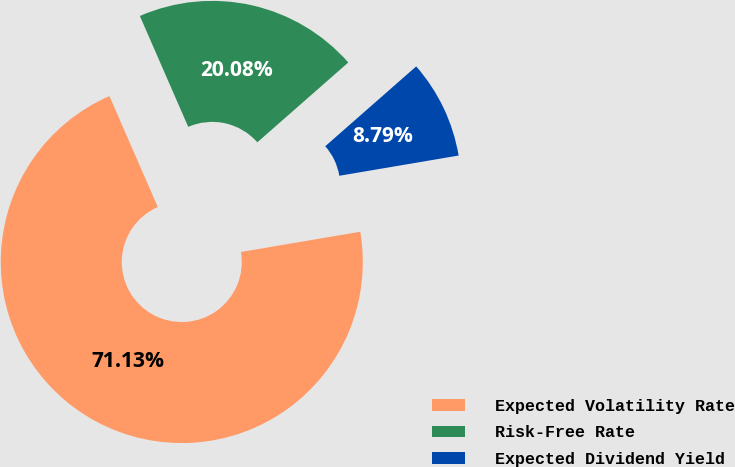Convert chart to OTSL. <chart><loc_0><loc_0><loc_500><loc_500><pie_chart><fcel>Expected Volatility Rate<fcel>Risk-Free Rate<fcel>Expected Dividend Yield<nl><fcel>71.13%<fcel>20.08%<fcel>8.79%<nl></chart> 